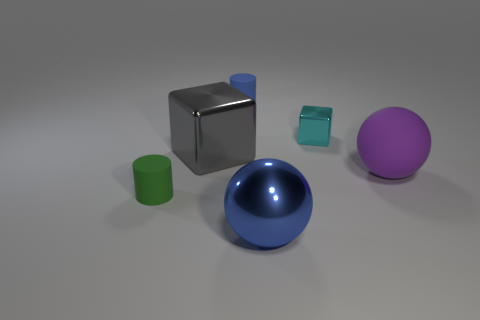Can you guess the purpose of this image or the context in which it might be used? The image seems to be a 3D rendering that could be used for various purposes. It might be a visual aid in a discussion about geometry, showcasing shapes and their properties. Alternatively, it could serve as a portfolio piece for a 3D artist, demonstrating skills in rendering and material settings. It may also be used in educational settings, allowing learners to identify shapes and understand concepts like reflection, shadow, and lighting in a controlled environment. 